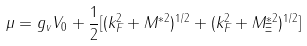Convert formula to latex. <formula><loc_0><loc_0><loc_500><loc_500>\mu = g _ { v } V _ { 0 } + \frac { 1 } { 2 } [ ( k _ { F } ^ { 2 } + M ^ { * 2 } ) ^ { 1 / 2 } + ( k _ { F } ^ { 2 } + M _ { \Xi } ^ { * 2 } ) ^ { 1 / 2 } ]</formula> 